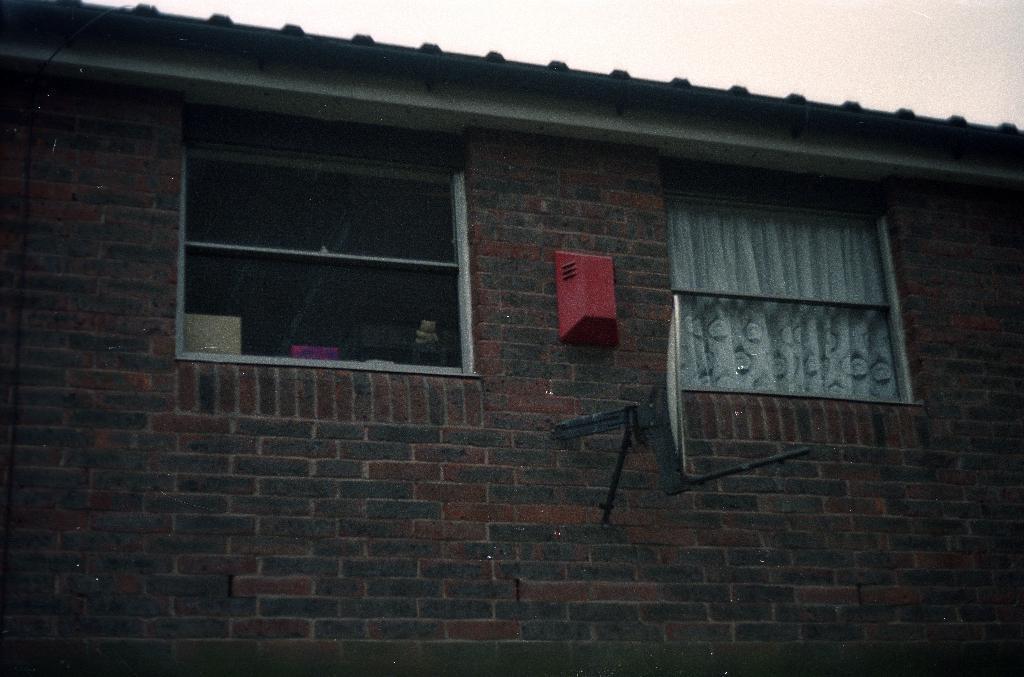Describe this image in one or two sentences. In this image we can see a building, curtain to the window, antenna to the wall and sky. 